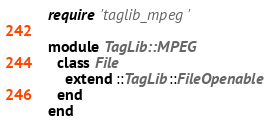Convert code to text. <code><loc_0><loc_0><loc_500><loc_500><_Ruby_>require 'taglib_mpeg'

module TagLib::MPEG
  class File
    extend ::TagLib::FileOpenable
  end
end
</code> 